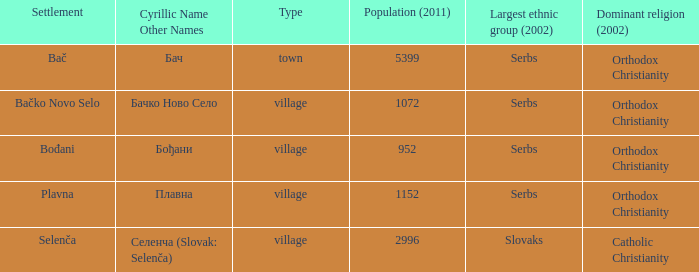How can you convert плавна into the latin alphabet? Plavna. 